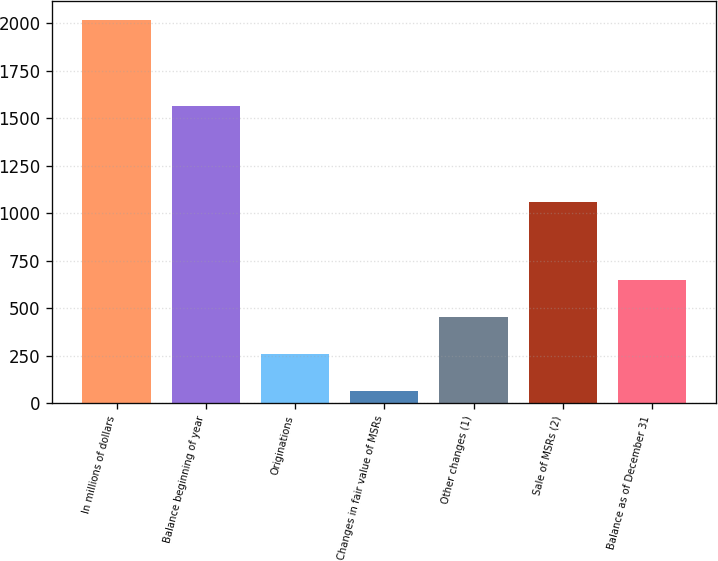Convert chart. <chart><loc_0><loc_0><loc_500><loc_500><bar_chart><fcel>In millions of dollars<fcel>Balance beginning of year<fcel>Originations<fcel>Changes in fair value of MSRs<fcel>Other changes (1)<fcel>Sale of MSRs (2)<fcel>Balance as of December 31<nl><fcel>2017<fcel>1564<fcel>260.2<fcel>65<fcel>455.4<fcel>1057<fcel>650.6<nl></chart> 